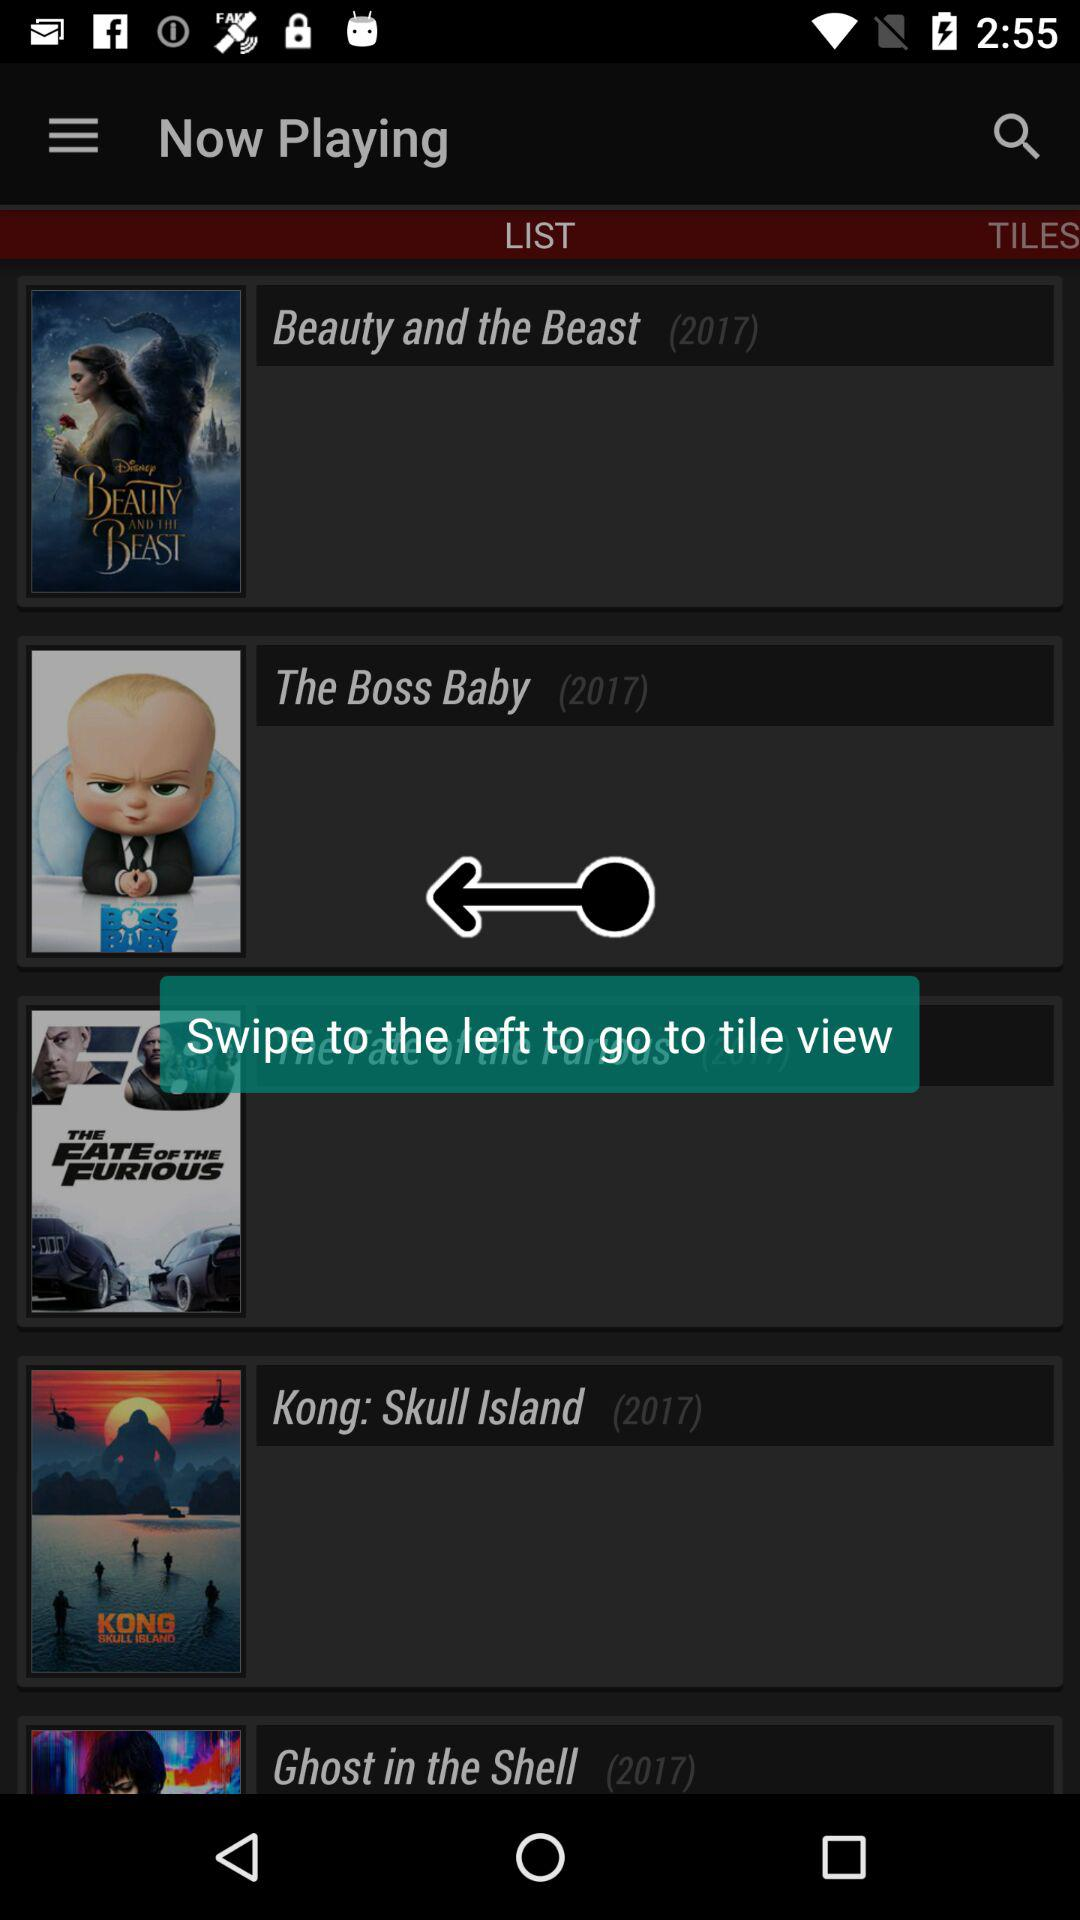What are the few names of the movies that were released in 2017? The movies were "Beauty and the Beast (2017)", "The Boss Baby (2017)", "The Fate of the Furious (2017)", "Kong: skull Island (2017)" and "Ghost in the Shell (2017)". 